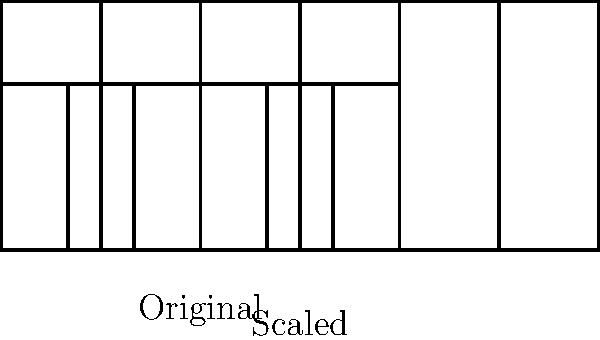As a record label owner, you want to create a unique album cover featuring a piano keyboard diagram. The original keyboard diagram is 12 cm wide, but you need to scale it up to fit a larger album cover that is 18 cm wide. What scale factor should you use to enlarge the keyboard diagram proportionally? To find the scale factor, we need to follow these steps:

1. Identify the original width: 12 cm
2. Identify the desired width: 18 cm
3. Calculate the scale factor using the formula:
   
   $$\text{Scale factor} = \frac{\text{New size}}{\text{Original size}}$$

4. Plug in the values:
   
   $$\text{Scale factor} = \frac{18 \text{ cm}}{12 \text{ cm}}$$

5. Simplify the fraction:
   
   $$\text{Scale factor} = \frac{3}{2} = 1.5$$

Therefore, to enlarge the keyboard diagram from 12 cm to 18 cm, you need to use a scale factor of 1.5 or 150%.
Answer: 1.5 